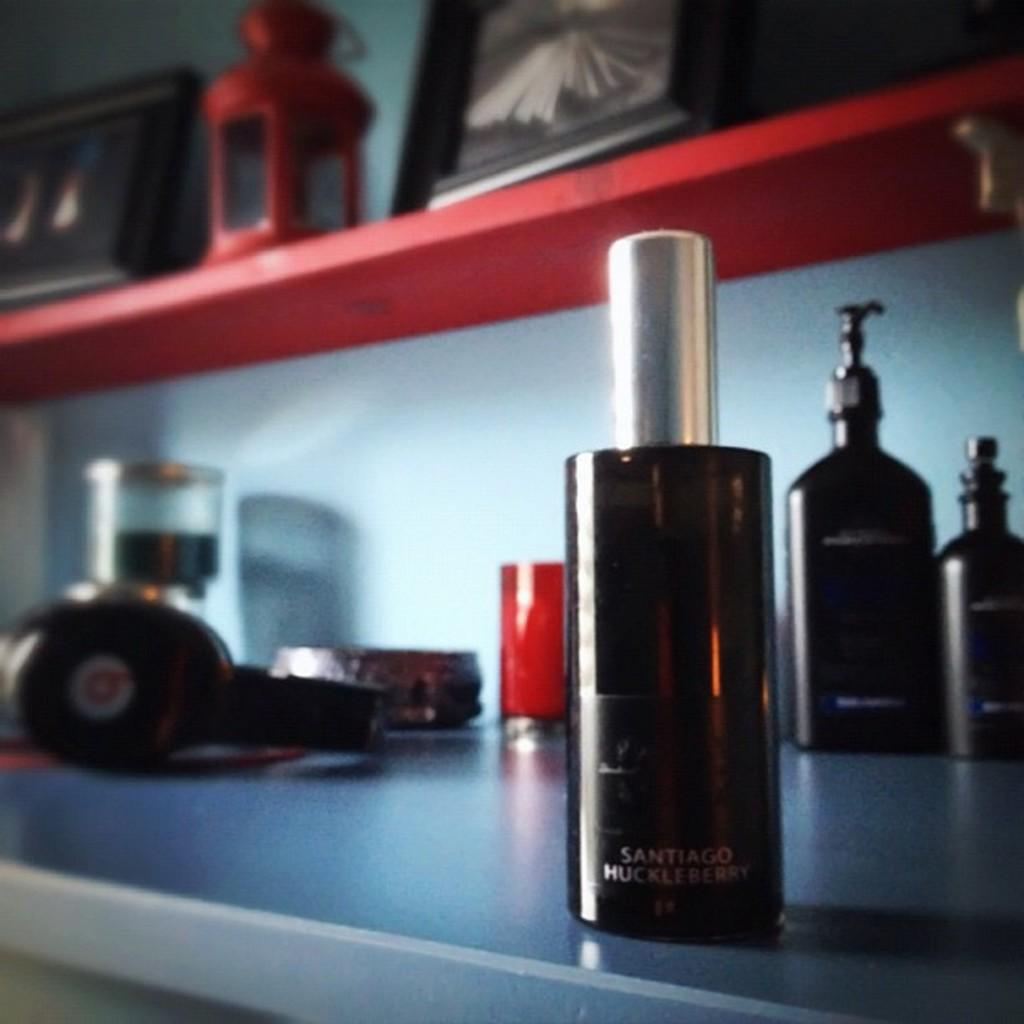<image>
Relay a brief, clear account of the picture shown. A spray bottle of Santiago Huckleberry perfume on the edge of the counter. 